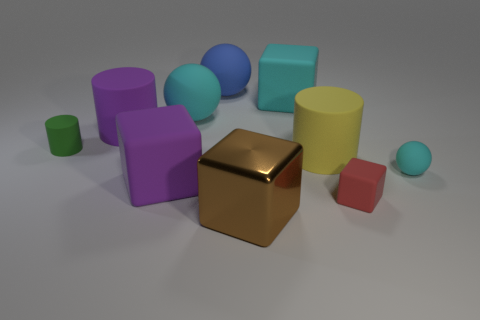Subtract all green blocks. Subtract all yellow balls. How many blocks are left? 4 Subtract all cubes. How many objects are left? 6 Add 7 green rubber cylinders. How many green rubber cylinders are left? 8 Add 7 purple rubber objects. How many purple rubber objects exist? 9 Subtract 1 cyan blocks. How many objects are left? 9 Subtract all big purple blocks. Subtract all large yellow spheres. How many objects are left? 9 